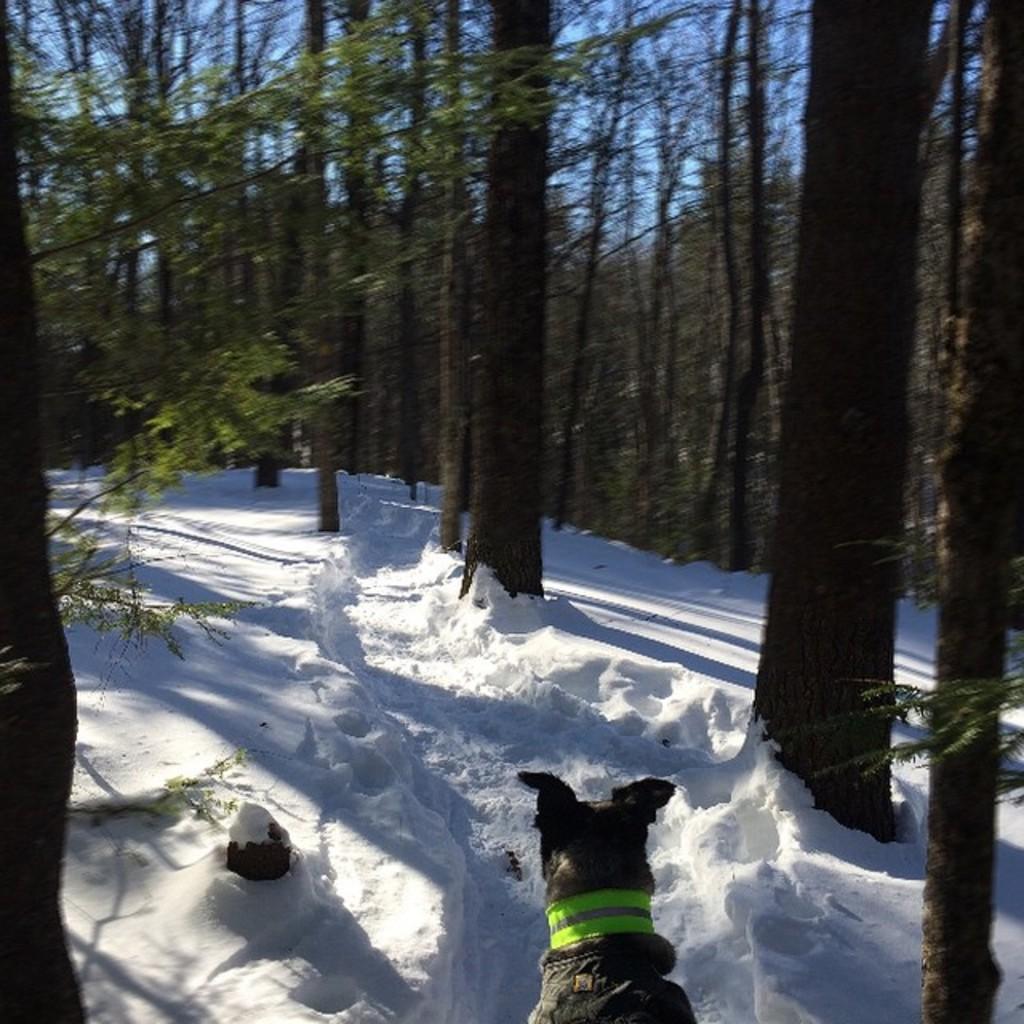Could you give a brief overview of what you see in this image? In this image I can see at the bottom there is the dog in the snow, at the top there are trees. 